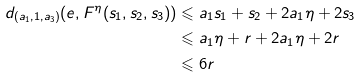Convert formula to latex. <formula><loc_0><loc_0><loc_500><loc_500>d _ { ( a _ { 1 } , 1 , a _ { 3 } ) } ( e , F ^ { \eta } ( s _ { 1 } , s _ { 2 } , s _ { 3 } ) ) & \leqslant a _ { 1 } s _ { 1 } + s _ { 2 } + 2 a _ { 1 } \eta + 2 s _ { 3 } \\ & \leqslant a _ { 1 } \eta + r + 2 a _ { 1 } \eta + 2 r \\ & \leqslant 6 r</formula> 